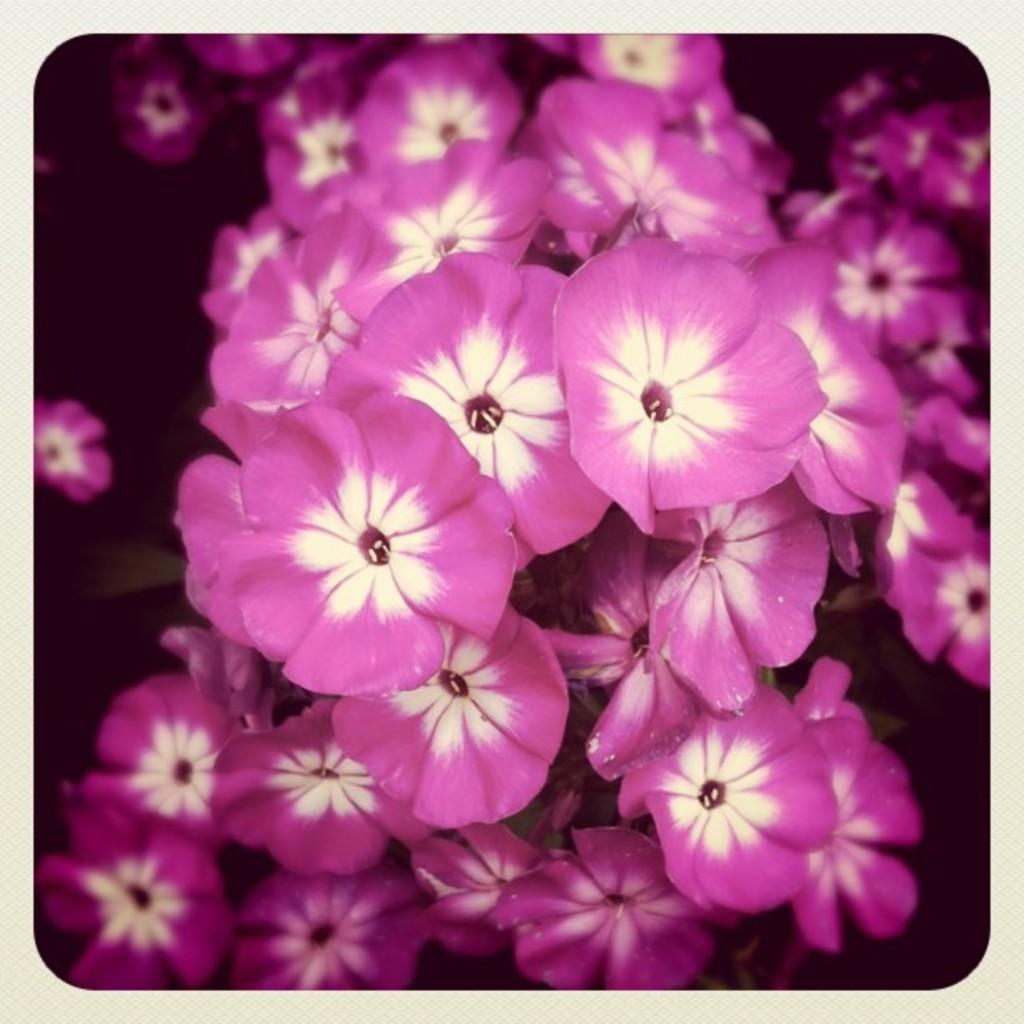What types of flowers are present in the image? There are purple flowers and white flowers in the image. Can you describe the background of the image? The background of the image is dark. What type of goat can be seen interacting with the flowers in the image? There is no goat present in the image; it only features flowers. What role does the manager play in the image? There is no mention of a manager in the image, as it only contains flowers and a dark background. 